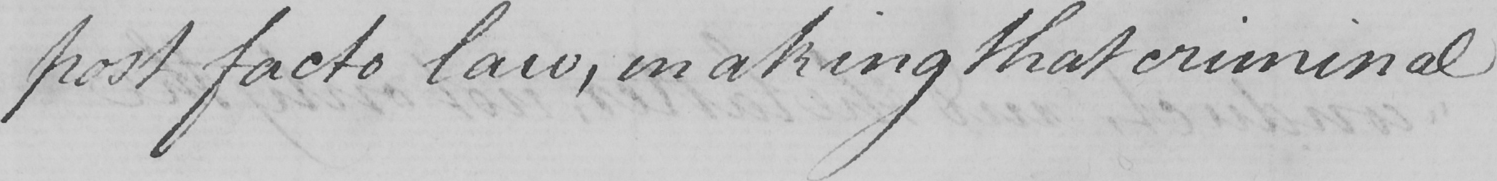Can you tell me what this handwritten text says? post facto law , making that criminal 